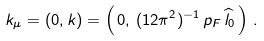<formula> <loc_0><loc_0><loc_500><loc_500>k _ { \mu } = ( 0 , { k } ) = \left ( \, 0 , \, ( 1 2 \pi ^ { 2 } ) ^ { - 1 } \, p _ { F } \, \widehat { l } _ { 0 } \, \right ) \, .</formula> 